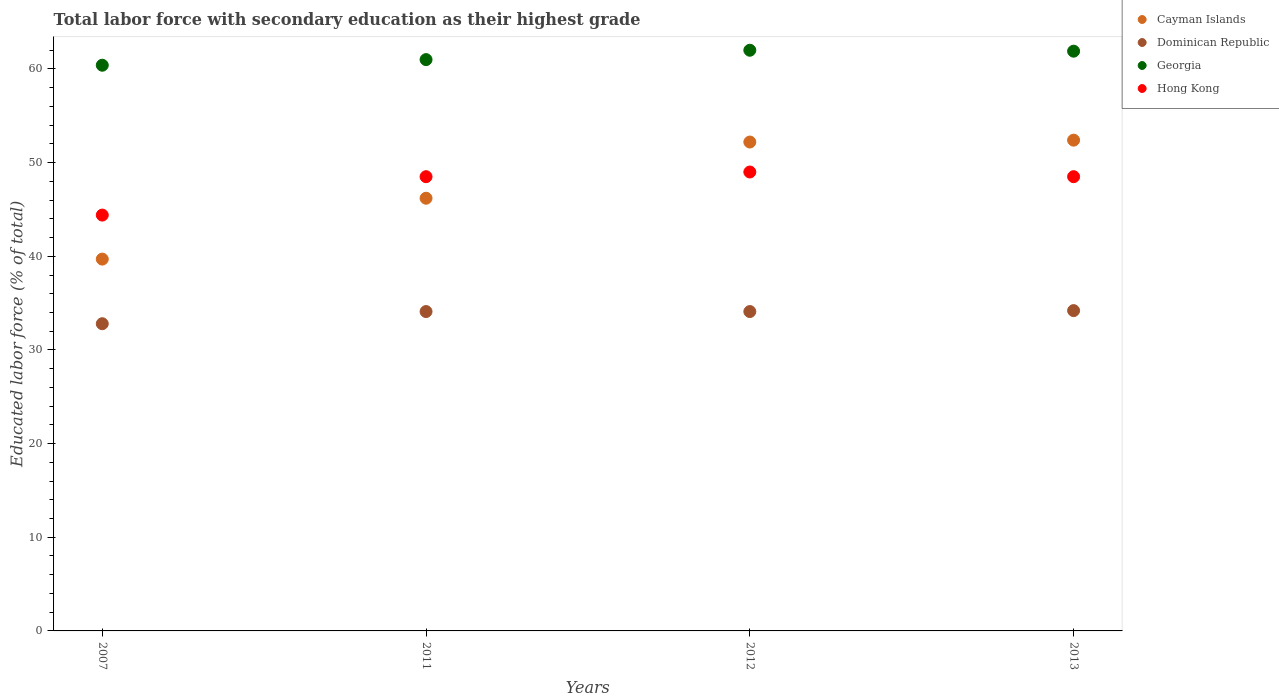What is the percentage of total labor force with primary education in Georgia in 2012?
Provide a short and direct response. 62. Across all years, what is the maximum percentage of total labor force with primary education in Cayman Islands?
Your response must be concise. 52.4. Across all years, what is the minimum percentage of total labor force with primary education in Georgia?
Offer a terse response. 60.4. What is the total percentage of total labor force with primary education in Cayman Islands in the graph?
Give a very brief answer. 190.5. What is the difference between the percentage of total labor force with primary education in Cayman Islands in 2011 and that in 2012?
Give a very brief answer. -6. What is the difference between the percentage of total labor force with primary education in Hong Kong in 2011 and the percentage of total labor force with primary education in Dominican Republic in 2012?
Your response must be concise. 14.4. What is the average percentage of total labor force with primary education in Cayman Islands per year?
Offer a very short reply. 47.63. In the year 2013, what is the difference between the percentage of total labor force with primary education in Georgia and percentage of total labor force with primary education in Hong Kong?
Give a very brief answer. 13.4. In how many years, is the percentage of total labor force with primary education in Dominican Republic greater than 10 %?
Provide a short and direct response. 4. What is the ratio of the percentage of total labor force with primary education in Dominican Republic in 2012 to that in 2013?
Provide a short and direct response. 1. What is the difference between the highest and the second highest percentage of total labor force with primary education in Hong Kong?
Provide a succinct answer. 0.5. What is the difference between the highest and the lowest percentage of total labor force with primary education in Cayman Islands?
Offer a terse response. 12.7. In how many years, is the percentage of total labor force with primary education in Hong Kong greater than the average percentage of total labor force with primary education in Hong Kong taken over all years?
Make the answer very short. 3. Is the sum of the percentage of total labor force with primary education in Georgia in 2011 and 2012 greater than the maximum percentage of total labor force with primary education in Dominican Republic across all years?
Provide a short and direct response. Yes. Is it the case that in every year, the sum of the percentage of total labor force with primary education in Hong Kong and percentage of total labor force with primary education in Cayman Islands  is greater than the sum of percentage of total labor force with primary education in Georgia and percentage of total labor force with primary education in Dominican Republic?
Your answer should be very brief. No. Is it the case that in every year, the sum of the percentage of total labor force with primary education in Cayman Islands and percentage of total labor force with primary education in Hong Kong  is greater than the percentage of total labor force with primary education in Dominican Republic?
Make the answer very short. Yes. Does the percentage of total labor force with primary education in Hong Kong monotonically increase over the years?
Offer a very short reply. No. Is the percentage of total labor force with primary education in Dominican Republic strictly less than the percentage of total labor force with primary education in Hong Kong over the years?
Offer a very short reply. Yes. How many dotlines are there?
Your answer should be very brief. 4. Are the values on the major ticks of Y-axis written in scientific E-notation?
Offer a terse response. No. Does the graph contain any zero values?
Keep it short and to the point. No. Does the graph contain grids?
Provide a succinct answer. No. What is the title of the graph?
Offer a terse response. Total labor force with secondary education as their highest grade. Does "Congo (Republic)" appear as one of the legend labels in the graph?
Provide a short and direct response. No. What is the label or title of the X-axis?
Your answer should be compact. Years. What is the label or title of the Y-axis?
Provide a succinct answer. Educated labor force (% of total). What is the Educated labor force (% of total) of Cayman Islands in 2007?
Provide a succinct answer. 39.7. What is the Educated labor force (% of total) of Dominican Republic in 2007?
Make the answer very short. 32.8. What is the Educated labor force (% of total) of Georgia in 2007?
Provide a succinct answer. 60.4. What is the Educated labor force (% of total) of Hong Kong in 2007?
Provide a succinct answer. 44.4. What is the Educated labor force (% of total) in Cayman Islands in 2011?
Your answer should be very brief. 46.2. What is the Educated labor force (% of total) in Dominican Republic in 2011?
Your response must be concise. 34.1. What is the Educated labor force (% of total) in Georgia in 2011?
Your answer should be compact. 61. What is the Educated labor force (% of total) of Hong Kong in 2011?
Offer a very short reply. 48.5. What is the Educated labor force (% of total) of Cayman Islands in 2012?
Offer a very short reply. 52.2. What is the Educated labor force (% of total) in Dominican Republic in 2012?
Keep it short and to the point. 34.1. What is the Educated labor force (% of total) in Georgia in 2012?
Your response must be concise. 62. What is the Educated labor force (% of total) of Cayman Islands in 2013?
Provide a short and direct response. 52.4. What is the Educated labor force (% of total) of Dominican Republic in 2013?
Offer a very short reply. 34.2. What is the Educated labor force (% of total) of Georgia in 2013?
Offer a terse response. 61.9. What is the Educated labor force (% of total) of Hong Kong in 2013?
Keep it short and to the point. 48.5. Across all years, what is the maximum Educated labor force (% of total) in Cayman Islands?
Your response must be concise. 52.4. Across all years, what is the maximum Educated labor force (% of total) of Dominican Republic?
Provide a short and direct response. 34.2. Across all years, what is the minimum Educated labor force (% of total) of Cayman Islands?
Your answer should be compact. 39.7. Across all years, what is the minimum Educated labor force (% of total) in Dominican Republic?
Offer a terse response. 32.8. Across all years, what is the minimum Educated labor force (% of total) of Georgia?
Your answer should be compact. 60.4. Across all years, what is the minimum Educated labor force (% of total) in Hong Kong?
Provide a short and direct response. 44.4. What is the total Educated labor force (% of total) of Cayman Islands in the graph?
Keep it short and to the point. 190.5. What is the total Educated labor force (% of total) of Dominican Republic in the graph?
Provide a short and direct response. 135.2. What is the total Educated labor force (% of total) in Georgia in the graph?
Give a very brief answer. 245.3. What is the total Educated labor force (% of total) in Hong Kong in the graph?
Ensure brevity in your answer.  190.4. What is the difference between the Educated labor force (% of total) in Cayman Islands in 2007 and that in 2011?
Your response must be concise. -6.5. What is the difference between the Educated labor force (% of total) of Dominican Republic in 2007 and that in 2011?
Offer a very short reply. -1.3. What is the difference between the Educated labor force (% of total) of Hong Kong in 2007 and that in 2011?
Offer a very short reply. -4.1. What is the difference between the Educated labor force (% of total) of Cayman Islands in 2007 and that in 2012?
Provide a short and direct response. -12.5. What is the difference between the Educated labor force (% of total) in Dominican Republic in 2007 and that in 2012?
Your response must be concise. -1.3. What is the difference between the Educated labor force (% of total) of Georgia in 2007 and that in 2012?
Make the answer very short. -1.6. What is the difference between the Educated labor force (% of total) of Hong Kong in 2007 and that in 2012?
Your response must be concise. -4.6. What is the difference between the Educated labor force (% of total) in Dominican Republic in 2007 and that in 2013?
Offer a very short reply. -1.4. What is the difference between the Educated labor force (% of total) of Hong Kong in 2007 and that in 2013?
Offer a terse response. -4.1. What is the difference between the Educated labor force (% of total) in Hong Kong in 2011 and that in 2012?
Your response must be concise. -0.5. What is the difference between the Educated labor force (% of total) in Dominican Republic in 2011 and that in 2013?
Provide a succinct answer. -0.1. What is the difference between the Educated labor force (% of total) of Hong Kong in 2011 and that in 2013?
Offer a very short reply. 0. What is the difference between the Educated labor force (% of total) in Georgia in 2012 and that in 2013?
Keep it short and to the point. 0.1. What is the difference between the Educated labor force (% of total) in Hong Kong in 2012 and that in 2013?
Give a very brief answer. 0.5. What is the difference between the Educated labor force (% of total) in Cayman Islands in 2007 and the Educated labor force (% of total) in Dominican Republic in 2011?
Give a very brief answer. 5.6. What is the difference between the Educated labor force (% of total) in Cayman Islands in 2007 and the Educated labor force (% of total) in Georgia in 2011?
Offer a very short reply. -21.3. What is the difference between the Educated labor force (% of total) in Cayman Islands in 2007 and the Educated labor force (% of total) in Hong Kong in 2011?
Your answer should be compact. -8.8. What is the difference between the Educated labor force (% of total) of Dominican Republic in 2007 and the Educated labor force (% of total) of Georgia in 2011?
Your response must be concise. -28.2. What is the difference between the Educated labor force (% of total) in Dominican Republic in 2007 and the Educated labor force (% of total) in Hong Kong in 2011?
Your answer should be compact. -15.7. What is the difference between the Educated labor force (% of total) of Georgia in 2007 and the Educated labor force (% of total) of Hong Kong in 2011?
Your answer should be very brief. 11.9. What is the difference between the Educated labor force (% of total) of Cayman Islands in 2007 and the Educated labor force (% of total) of Georgia in 2012?
Provide a succinct answer. -22.3. What is the difference between the Educated labor force (% of total) in Cayman Islands in 2007 and the Educated labor force (% of total) in Hong Kong in 2012?
Offer a very short reply. -9.3. What is the difference between the Educated labor force (% of total) in Dominican Republic in 2007 and the Educated labor force (% of total) in Georgia in 2012?
Keep it short and to the point. -29.2. What is the difference between the Educated labor force (% of total) in Dominican Republic in 2007 and the Educated labor force (% of total) in Hong Kong in 2012?
Keep it short and to the point. -16.2. What is the difference between the Educated labor force (% of total) in Cayman Islands in 2007 and the Educated labor force (% of total) in Georgia in 2013?
Offer a terse response. -22.2. What is the difference between the Educated labor force (% of total) of Cayman Islands in 2007 and the Educated labor force (% of total) of Hong Kong in 2013?
Your answer should be compact. -8.8. What is the difference between the Educated labor force (% of total) in Dominican Republic in 2007 and the Educated labor force (% of total) in Georgia in 2013?
Give a very brief answer. -29.1. What is the difference between the Educated labor force (% of total) of Dominican Republic in 2007 and the Educated labor force (% of total) of Hong Kong in 2013?
Give a very brief answer. -15.7. What is the difference between the Educated labor force (% of total) of Cayman Islands in 2011 and the Educated labor force (% of total) of Dominican Republic in 2012?
Ensure brevity in your answer.  12.1. What is the difference between the Educated labor force (% of total) of Cayman Islands in 2011 and the Educated labor force (% of total) of Georgia in 2012?
Offer a terse response. -15.8. What is the difference between the Educated labor force (% of total) in Cayman Islands in 2011 and the Educated labor force (% of total) in Hong Kong in 2012?
Provide a succinct answer. -2.8. What is the difference between the Educated labor force (% of total) in Dominican Republic in 2011 and the Educated labor force (% of total) in Georgia in 2012?
Your answer should be compact. -27.9. What is the difference between the Educated labor force (% of total) of Dominican Republic in 2011 and the Educated labor force (% of total) of Hong Kong in 2012?
Ensure brevity in your answer.  -14.9. What is the difference between the Educated labor force (% of total) of Georgia in 2011 and the Educated labor force (% of total) of Hong Kong in 2012?
Your response must be concise. 12. What is the difference between the Educated labor force (% of total) in Cayman Islands in 2011 and the Educated labor force (% of total) in Dominican Republic in 2013?
Make the answer very short. 12. What is the difference between the Educated labor force (% of total) in Cayman Islands in 2011 and the Educated labor force (% of total) in Georgia in 2013?
Keep it short and to the point. -15.7. What is the difference between the Educated labor force (% of total) of Dominican Republic in 2011 and the Educated labor force (% of total) of Georgia in 2013?
Offer a very short reply. -27.8. What is the difference between the Educated labor force (% of total) in Dominican Republic in 2011 and the Educated labor force (% of total) in Hong Kong in 2013?
Make the answer very short. -14.4. What is the difference between the Educated labor force (% of total) of Georgia in 2011 and the Educated labor force (% of total) of Hong Kong in 2013?
Your answer should be compact. 12.5. What is the difference between the Educated labor force (% of total) of Cayman Islands in 2012 and the Educated labor force (% of total) of Hong Kong in 2013?
Ensure brevity in your answer.  3.7. What is the difference between the Educated labor force (% of total) of Dominican Republic in 2012 and the Educated labor force (% of total) of Georgia in 2013?
Provide a succinct answer. -27.8. What is the difference between the Educated labor force (% of total) in Dominican Republic in 2012 and the Educated labor force (% of total) in Hong Kong in 2013?
Offer a terse response. -14.4. What is the average Educated labor force (% of total) in Cayman Islands per year?
Your response must be concise. 47.62. What is the average Educated labor force (% of total) in Dominican Republic per year?
Provide a short and direct response. 33.8. What is the average Educated labor force (% of total) in Georgia per year?
Offer a very short reply. 61.33. What is the average Educated labor force (% of total) in Hong Kong per year?
Offer a terse response. 47.6. In the year 2007, what is the difference between the Educated labor force (% of total) in Cayman Islands and Educated labor force (% of total) in Georgia?
Offer a very short reply. -20.7. In the year 2007, what is the difference between the Educated labor force (% of total) in Cayman Islands and Educated labor force (% of total) in Hong Kong?
Make the answer very short. -4.7. In the year 2007, what is the difference between the Educated labor force (% of total) in Dominican Republic and Educated labor force (% of total) in Georgia?
Ensure brevity in your answer.  -27.6. In the year 2007, what is the difference between the Educated labor force (% of total) in Dominican Republic and Educated labor force (% of total) in Hong Kong?
Make the answer very short. -11.6. In the year 2011, what is the difference between the Educated labor force (% of total) in Cayman Islands and Educated labor force (% of total) in Georgia?
Provide a succinct answer. -14.8. In the year 2011, what is the difference between the Educated labor force (% of total) in Dominican Republic and Educated labor force (% of total) in Georgia?
Provide a short and direct response. -26.9. In the year 2011, what is the difference between the Educated labor force (% of total) of Dominican Republic and Educated labor force (% of total) of Hong Kong?
Your answer should be very brief. -14.4. In the year 2011, what is the difference between the Educated labor force (% of total) of Georgia and Educated labor force (% of total) of Hong Kong?
Offer a very short reply. 12.5. In the year 2012, what is the difference between the Educated labor force (% of total) in Cayman Islands and Educated labor force (% of total) in Dominican Republic?
Make the answer very short. 18.1. In the year 2012, what is the difference between the Educated labor force (% of total) in Cayman Islands and Educated labor force (% of total) in Hong Kong?
Your answer should be very brief. 3.2. In the year 2012, what is the difference between the Educated labor force (% of total) in Dominican Republic and Educated labor force (% of total) in Georgia?
Your answer should be compact. -27.9. In the year 2012, what is the difference between the Educated labor force (% of total) of Dominican Republic and Educated labor force (% of total) of Hong Kong?
Keep it short and to the point. -14.9. In the year 2013, what is the difference between the Educated labor force (% of total) in Cayman Islands and Educated labor force (% of total) in Georgia?
Make the answer very short. -9.5. In the year 2013, what is the difference between the Educated labor force (% of total) of Cayman Islands and Educated labor force (% of total) of Hong Kong?
Offer a very short reply. 3.9. In the year 2013, what is the difference between the Educated labor force (% of total) in Dominican Republic and Educated labor force (% of total) in Georgia?
Offer a very short reply. -27.7. In the year 2013, what is the difference between the Educated labor force (% of total) in Dominican Republic and Educated labor force (% of total) in Hong Kong?
Keep it short and to the point. -14.3. What is the ratio of the Educated labor force (% of total) of Cayman Islands in 2007 to that in 2011?
Provide a short and direct response. 0.86. What is the ratio of the Educated labor force (% of total) in Dominican Republic in 2007 to that in 2011?
Provide a short and direct response. 0.96. What is the ratio of the Educated labor force (% of total) of Georgia in 2007 to that in 2011?
Your answer should be very brief. 0.99. What is the ratio of the Educated labor force (% of total) in Hong Kong in 2007 to that in 2011?
Make the answer very short. 0.92. What is the ratio of the Educated labor force (% of total) of Cayman Islands in 2007 to that in 2012?
Offer a very short reply. 0.76. What is the ratio of the Educated labor force (% of total) of Dominican Republic in 2007 to that in 2012?
Provide a short and direct response. 0.96. What is the ratio of the Educated labor force (% of total) in Georgia in 2007 to that in 2012?
Provide a succinct answer. 0.97. What is the ratio of the Educated labor force (% of total) of Hong Kong in 2007 to that in 2012?
Keep it short and to the point. 0.91. What is the ratio of the Educated labor force (% of total) of Cayman Islands in 2007 to that in 2013?
Offer a very short reply. 0.76. What is the ratio of the Educated labor force (% of total) in Dominican Republic in 2007 to that in 2013?
Ensure brevity in your answer.  0.96. What is the ratio of the Educated labor force (% of total) of Georgia in 2007 to that in 2013?
Provide a short and direct response. 0.98. What is the ratio of the Educated labor force (% of total) in Hong Kong in 2007 to that in 2013?
Your response must be concise. 0.92. What is the ratio of the Educated labor force (% of total) in Cayman Islands in 2011 to that in 2012?
Make the answer very short. 0.89. What is the ratio of the Educated labor force (% of total) in Dominican Republic in 2011 to that in 2012?
Your answer should be very brief. 1. What is the ratio of the Educated labor force (% of total) of Georgia in 2011 to that in 2012?
Make the answer very short. 0.98. What is the ratio of the Educated labor force (% of total) in Hong Kong in 2011 to that in 2012?
Give a very brief answer. 0.99. What is the ratio of the Educated labor force (% of total) in Cayman Islands in 2011 to that in 2013?
Provide a succinct answer. 0.88. What is the ratio of the Educated labor force (% of total) in Georgia in 2011 to that in 2013?
Offer a terse response. 0.99. What is the ratio of the Educated labor force (% of total) of Dominican Republic in 2012 to that in 2013?
Keep it short and to the point. 1. What is the ratio of the Educated labor force (% of total) in Georgia in 2012 to that in 2013?
Make the answer very short. 1. What is the ratio of the Educated labor force (% of total) in Hong Kong in 2012 to that in 2013?
Give a very brief answer. 1.01. What is the difference between the highest and the second highest Educated labor force (% of total) in Dominican Republic?
Your answer should be compact. 0.1. What is the difference between the highest and the second highest Educated labor force (% of total) in Georgia?
Provide a short and direct response. 0.1. What is the difference between the highest and the lowest Educated labor force (% of total) of Cayman Islands?
Offer a terse response. 12.7. What is the difference between the highest and the lowest Educated labor force (% of total) of Dominican Republic?
Your answer should be compact. 1.4. What is the difference between the highest and the lowest Educated labor force (% of total) of Hong Kong?
Ensure brevity in your answer.  4.6. 